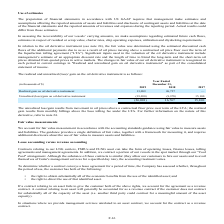From Golar Lng's financial document, In which years was the realized and unrealized (loss)/ gain on the oil derivative instrument recorded for? The document contains multiple relevant values: 2019, 2018, 2017. From the document: "thousands of $) Year Ended December 31, 2019 2018 2017 (in thousands of $) Year Ended December 31, 2019 2018 2017 (in thousands of $) Year Ended Decem..." Also, How was the fair value of oil derivative instrument determined? using the estimated discounted cash flows of the additional payments due to us as a result of oil prices moving above a contractual oil price floor over the term of the liquefaction tolling agreement ("LTA").. The document states: "ument (see note 24), the fair value was determined using the estimated discounted cash flows of the additional payments due to us as a result of oil p..." Also, What inputs were used in the valuation of the oil derivative instrument? management’s estimate of an appropriate discount rate and the length of time to blend the long-term and the short-term oil prices obtained from quoted prices in active markets.. The document states: "valuation of the oil derivative instrument include management’s estimate of an appropriate discount rate and the length of time to blend the long-term..." Additionally, In which year was the unrealized loss on oil derivative instrument the highest? According to the financial document, 2019. The relevant text states: "(in thousands of $) Year Ended December 31, 2019 2018 2017..." Also, can you calculate: What was the change in realized gain on oil derivative instrument from 2017 to 2018? Based on the calculation: 26,737 - 0 , the result is 26737 (in thousands). This is based on the information: "Realized gain on oil derivative instrument 13,089 26,737 — Realized gain on oil derivative instrument 13,089 26,737 —..." The key data points involved are: 0, 26,737. Also, can you calculate: What was the percentage change in total realized and unrealized (loss)/ gain on the oil derivative instrument from 2017 to 2018? To answer this question, I need to perform calculations using the financial data. The calculation is: (16,767 - 15,100)/15,100 , which equals 11.04 (percentage). This is based on the information: "ative instrument (39,090) (9,970) 15,100 (26,001) 16,767 15,100 ain on oil derivative instrument (39,090) (9,970) 15,100 (26,001) 16,767 15,100..." The key data points involved are: 15,100, 16,767. 